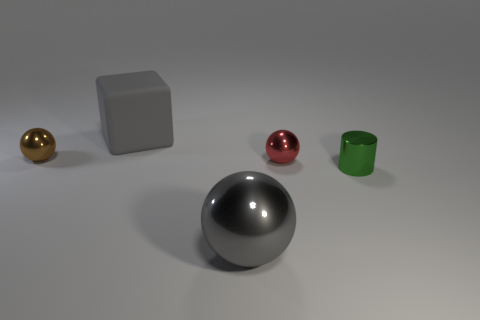Subtract all big gray balls. How many balls are left? 2 Add 2 tiny red objects. How many objects exist? 7 Subtract 2 balls. How many balls are left? 1 Subtract all balls. How many objects are left? 2 Subtract all big blue metallic spheres. Subtract all big gray cubes. How many objects are left? 4 Add 5 large gray matte things. How many large gray matte things are left? 6 Add 1 gray things. How many gray things exist? 3 Subtract all red balls. How many balls are left? 2 Subtract 0 brown cylinders. How many objects are left? 5 Subtract all red cubes. Subtract all yellow balls. How many cubes are left? 1 